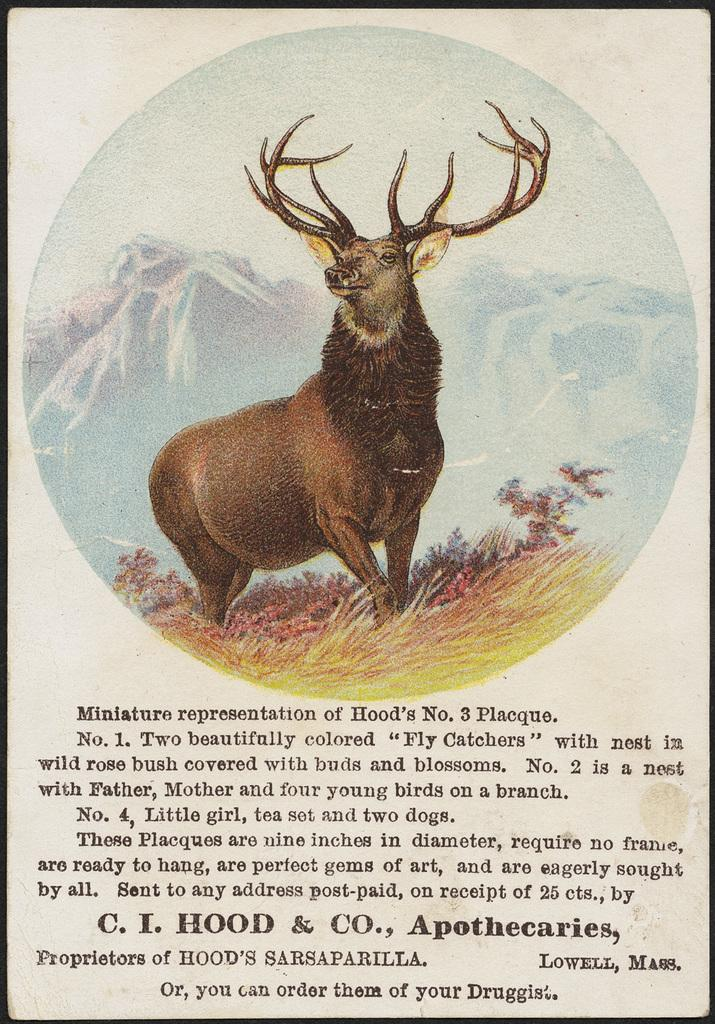What type of landscape is depicted in the pictures in the image? The pictures in the image depict hills, sky, and grass. Are there any animals shown in the pictures? Yes, there are pictures of deer in the image. What is the text at the bottom of the image? The text at the bottom of the image is not specified in the facts provided. What is the color of the sky in the pictures? The color of the sky in the pictures is not specified in the facts provided. What type of cake is being discussed in the image? There is no cake or discussion present in the image; it features pictures of hills, sky, deer, and grass with text at the bottom. What is the source of humor in the image? There is no humor or source of humor present in the image; it features pictures of hills, sky, deer, and grass with text at the bottom. 